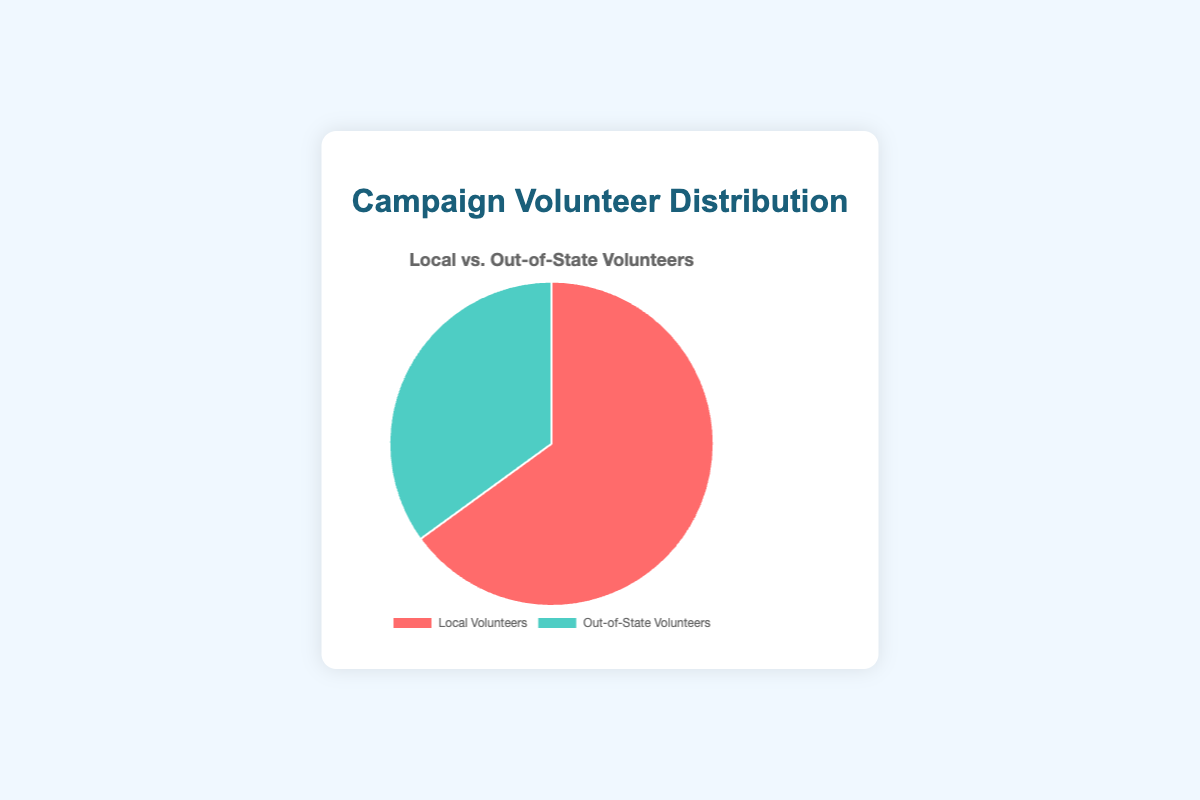What's the percentage of local volunteers? The chart shows two segments: Local Volunteers and Out-of-State Volunteers. The segment representing Local Volunteers is labeled with 65%.
Answer: 65% What's the percentage of out-of-state volunteers? The chart shows two segments: Local Volunteers and Out-of-State Volunteers. The segment representing Out-of-State Volunteers is labeled with 35%.
Answer: 35% Which group has a greater percentage, local or out-of-state volunteers? The chart shows that Local Volunteers have 65%, whereas Out-of-State Volunteers have 35%. Since 65% is greater than 35%, Local Volunteers have a greater percentage.
Answer: Local Volunteers How much greater is the percentage of local volunteers compared to out-of-state volunteers? To determine how much greater one percentage is compared to another, subtract the smaller percentage from the larger percentage: 65% (Local) - 35% (Out-of-State) = 30%.
Answer: 30% What fraction of the total volunteers are out-of-state volunteers? The percentage of out-of-state volunteers is given as 35%. To convert this percentage into a fraction, we divide by 100: 35/100 = 7/20.
Answer: 7/20 Which segment of the pie chart is represented by a red color? The chart legend and the pie chart show that Local Volunteers are represented by the red color.
Answer: Local Volunteers Which segment of the pie chart is represented by a green color? The chart legend and the pie chart show that Out-of-State Volunteers are represented by the green color.
Answer: Out-of-State Volunteers If there are 200 total volunteers, how many of them are out-of-state volunteers? We know 35% of the total volunteers are out-of-state. To find the number, multiply the total number of volunteers by the percentage (converted to a decimal): 200 * 0.35 = 70.
Answer: 70 If the pie chart were divided equally, what would be the percentage of each group, and how does it compare to the current distribution? If divided equally, each group would have 50% (100% / 2). Comparing this to the current distribution: Local Volunteers (65%) have 15% more than equal share, and Out-of-State Volunteers (35%) have 15% less than equal share.
Answer: Local: 15% more, Out-of-State: 15% less What is the average percentage of local and out-of-state volunteers? To find the average, add the two percentages and divide by the number of groups: (65% + 35%) / 2 = 100% / 2 = 50%.
Answer: 50% 